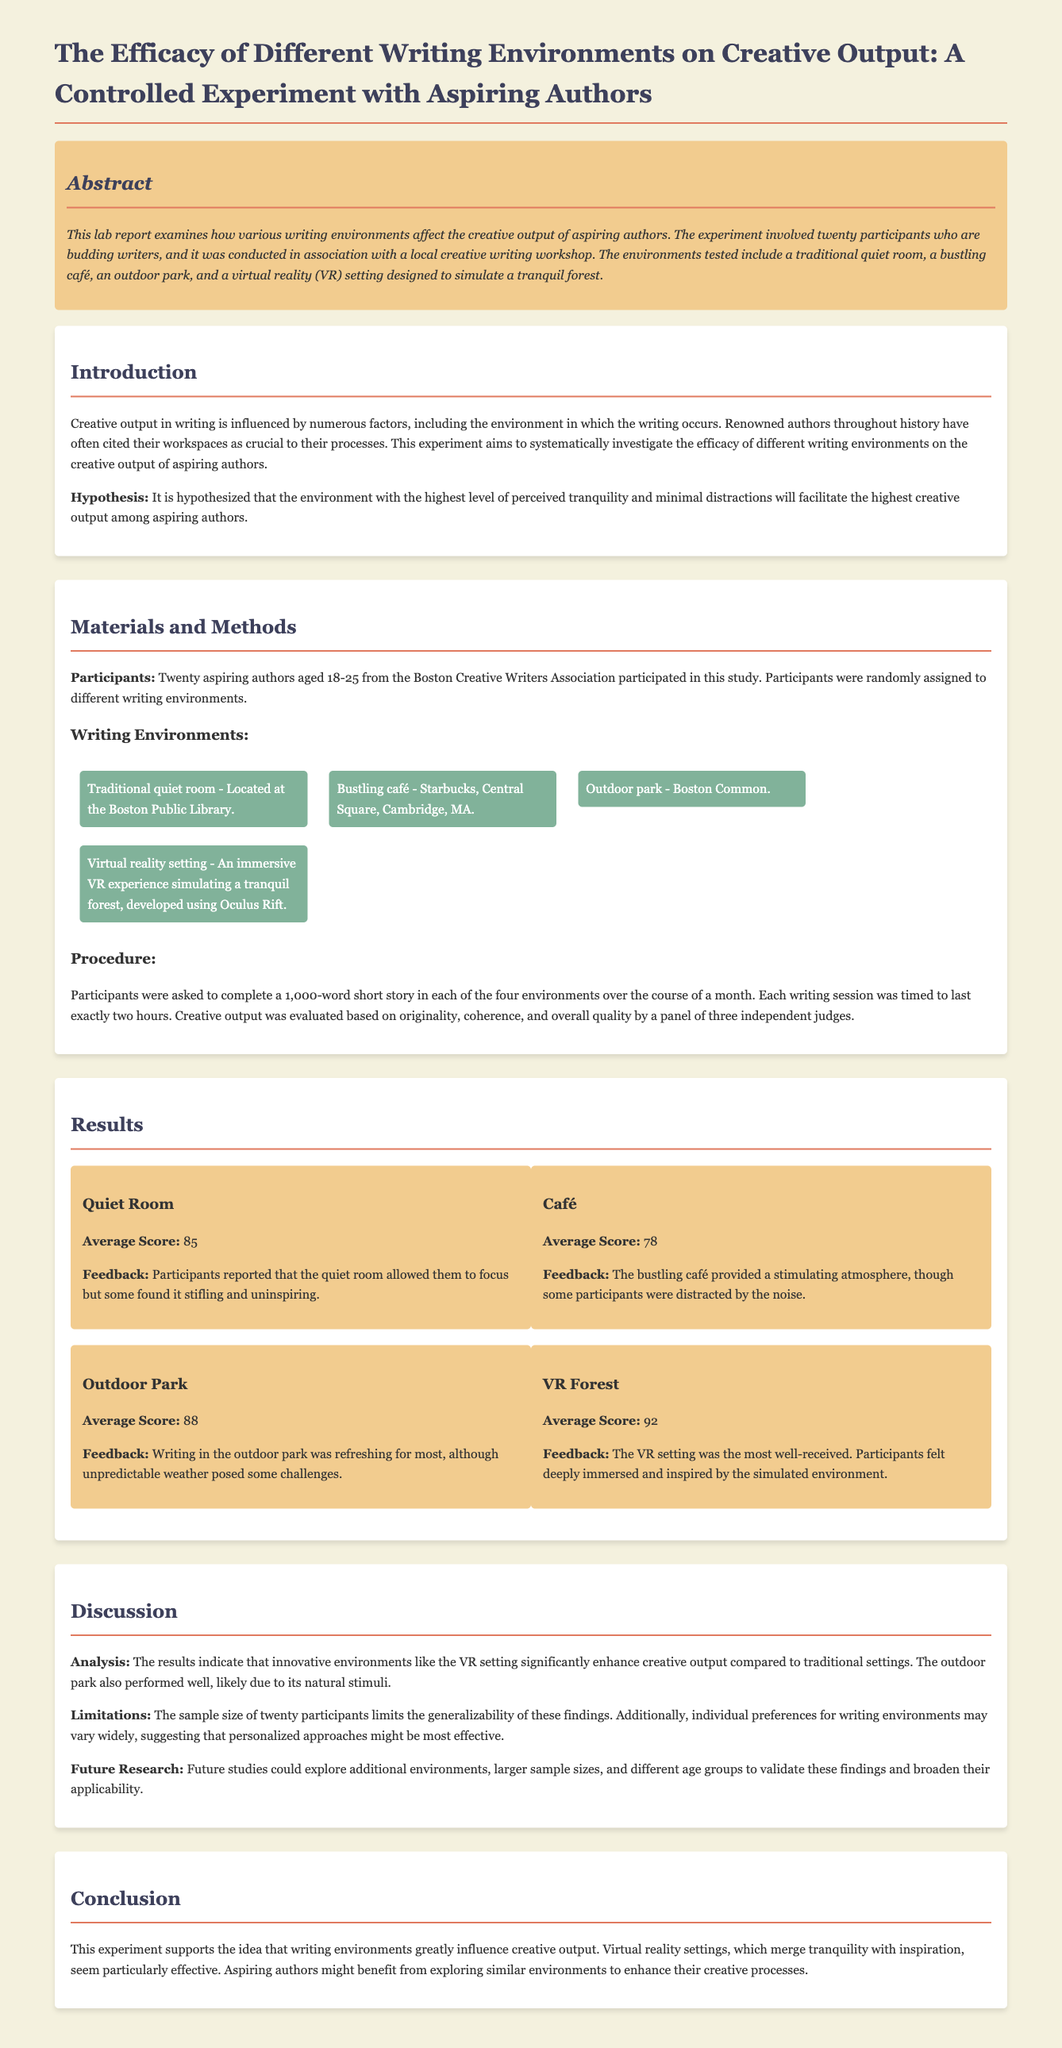What was the hypothesis of the experiment? The hypothesis states that the environment with the highest level of perceived tranquility and minimal distractions will facilitate the highest creative output among aspiring authors.
Answer: The environment with the highest level of perceived tranquility and minimal distractions How many participants were involved in the study? The number of participants is explicitly stated in the document as twenty aspiring authors.
Answer: Twenty What was the average score for the Virtual Reality setting? The average score for the VR setting is detailed in the results section, which shows the score as 92.
Answer: 92 Which writing environment had the lowest feedback score? The feedback scores indicate that the café had the lowest average score of 78.
Answer: Café What issue did participants encounter while writing in the outdoor park? The document indicates that unpredictable weather posed some challenges for participants in the outdoor park.
Answer: Unpredictable weather What is mentioned as a limitation of the study? The limitation outlined in the discussion section refers to the sample size of twenty participants, which limits the generalizability of the findings.
Answer: Sample size of twenty participants Which writing environment provided the most immersive experience? The document states that the VR setting was the most well-received and provided a deeply immersive experience.
Answer: VR setting What is one suggested area for future research? The suggestion for future research includes exploring additional environments to validate the findings.
Answer: Additional environments 